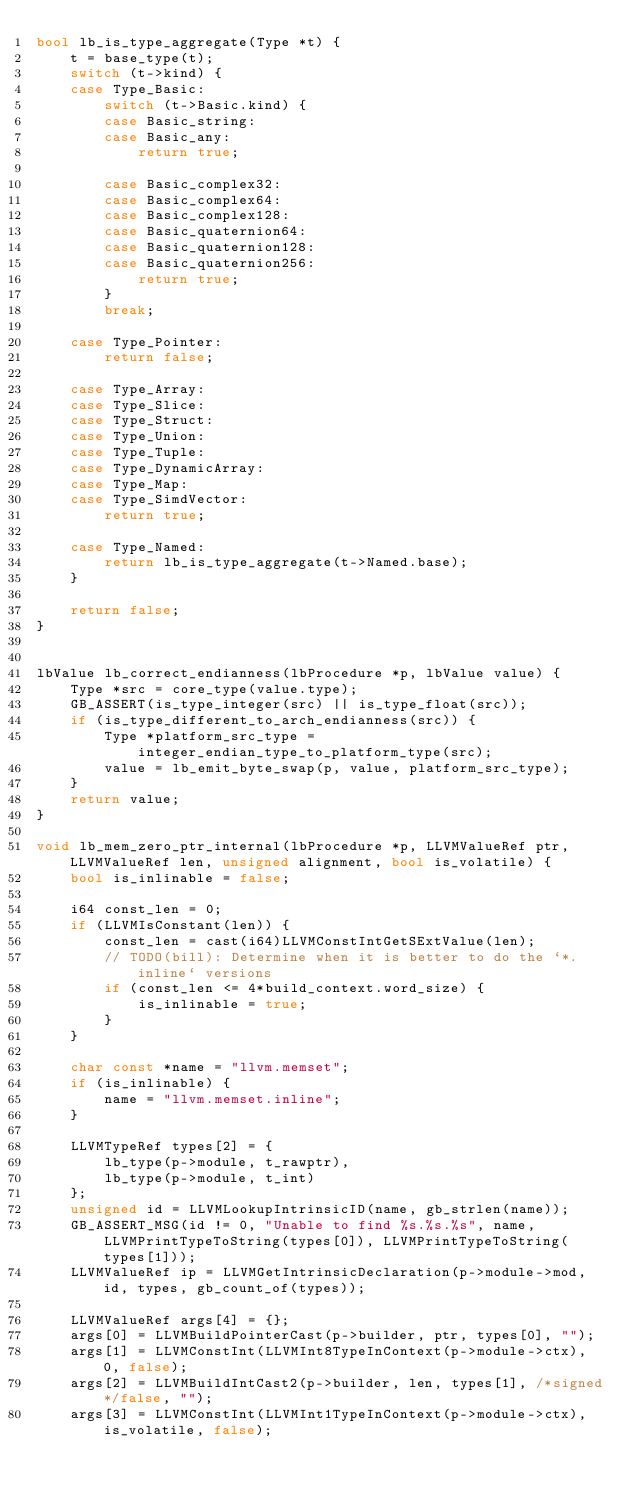<code> <loc_0><loc_0><loc_500><loc_500><_C++_>bool lb_is_type_aggregate(Type *t) {
	t = base_type(t);
	switch (t->kind) {
	case Type_Basic:
		switch (t->Basic.kind) {
		case Basic_string:
		case Basic_any:
			return true;

		case Basic_complex32:
		case Basic_complex64:
		case Basic_complex128:
		case Basic_quaternion64:
		case Basic_quaternion128:
		case Basic_quaternion256:
			return true;
		}
		break;

	case Type_Pointer:
		return false;

	case Type_Array:
	case Type_Slice:
	case Type_Struct:
	case Type_Union:
	case Type_Tuple:
	case Type_DynamicArray:
	case Type_Map:
	case Type_SimdVector:
		return true;

	case Type_Named:
		return lb_is_type_aggregate(t->Named.base);
	}

	return false;
}


lbValue lb_correct_endianness(lbProcedure *p, lbValue value) {
	Type *src = core_type(value.type);
	GB_ASSERT(is_type_integer(src) || is_type_float(src));
	if (is_type_different_to_arch_endianness(src)) {
		Type *platform_src_type = integer_endian_type_to_platform_type(src);
		value = lb_emit_byte_swap(p, value, platform_src_type);
	}
	return value;
}

void lb_mem_zero_ptr_internal(lbProcedure *p, LLVMValueRef ptr, LLVMValueRef len, unsigned alignment, bool is_volatile) {
	bool is_inlinable = false;

	i64 const_len = 0;
	if (LLVMIsConstant(len)) {
		const_len = cast(i64)LLVMConstIntGetSExtValue(len);
		// TODO(bill): Determine when it is better to do the `*.inline` versions
		if (const_len <= 4*build_context.word_size) {
			is_inlinable = true;
		}
	}

	char const *name = "llvm.memset";
	if (is_inlinable) {
		name = "llvm.memset.inline";
	}

	LLVMTypeRef types[2] = {
		lb_type(p->module, t_rawptr),
		lb_type(p->module, t_int)
	};
	unsigned id = LLVMLookupIntrinsicID(name, gb_strlen(name));
	GB_ASSERT_MSG(id != 0, "Unable to find %s.%s.%s", name, LLVMPrintTypeToString(types[0]), LLVMPrintTypeToString(types[1]));
	LLVMValueRef ip = LLVMGetIntrinsicDeclaration(p->module->mod, id, types, gb_count_of(types));

	LLVMValueRef args[4] = {};
	args[0] = LLVMBuildPointerCast(p->builder, ptr, types[0], "");
	args[1] = LLVMConstInt(LLVMInt8TypeInContext(p->module->ctx), 0, false);
	args[2] = LLVMBuildIntCast2(p->builder, len, types[1], /*signed*/false, "");
	args[3] = LLVMConstInt(LLVMInt1TypeInContext(p->module->ctx), is_volatile, false);
</code> 